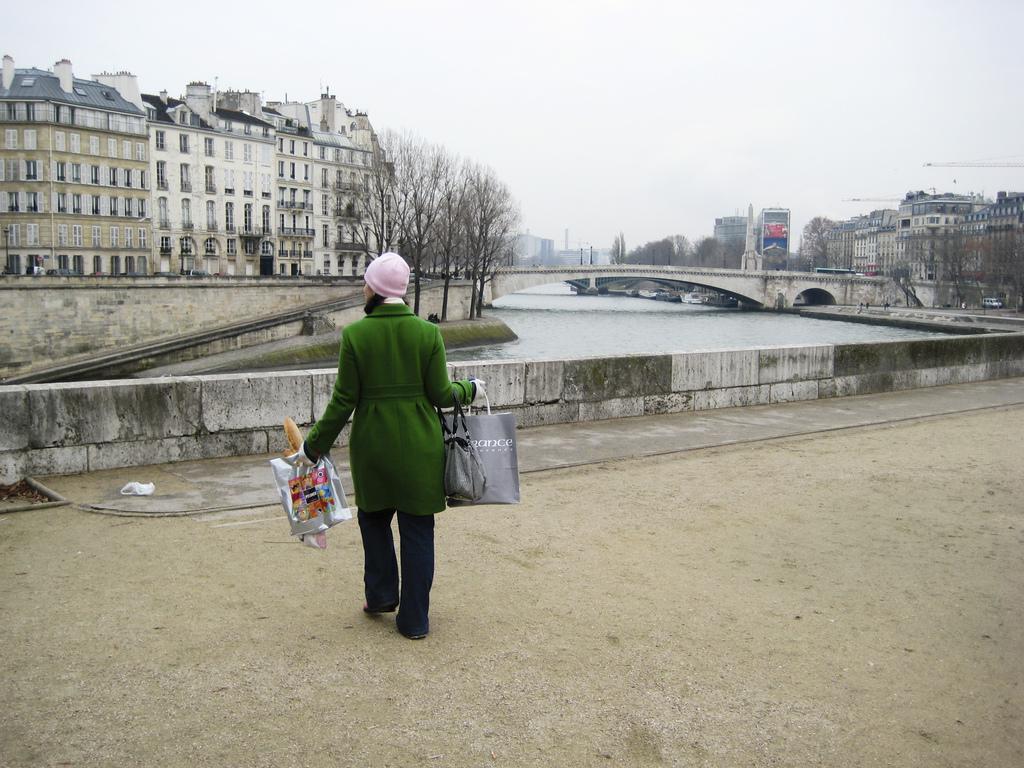Can you describe this image briefly? In this image I can see a person wearing green, pink and blue colored dress is standing and holding few bags in her hand. I can see the wall, the water, the bridge, few trees, few vehicles and few buildings. In the background I can see the sky. 